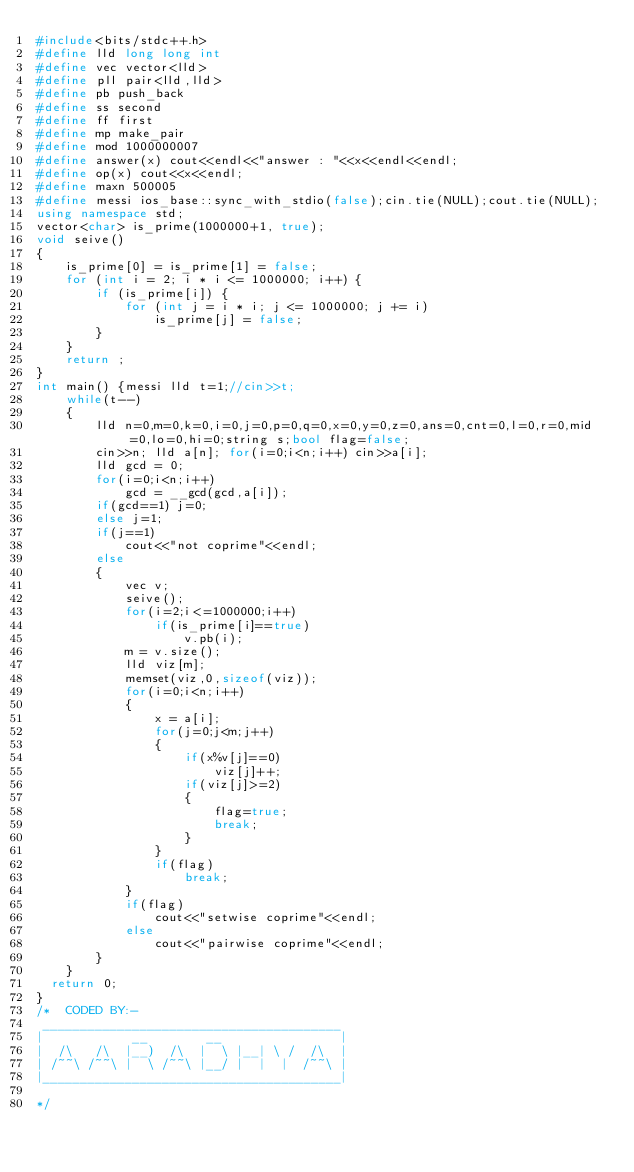Convert code to text. <code><loc_0><loc_0><loc_500><loc_500><_C++_>#include<bits/stdc++.h>
#define lld long long int
#define vec vector<lld>
#define pll pair<lld,lld>
#define pb push_back
#define ss second
#define ff first
#define mp make_pair
#define mod 1000000007
#define answer(x) cout<<endl<<"answer : "<<x<<endl<<endl;
#define op(x) cout<<x<<endl;
#define maxn 500005
#define messi ios_base::sync_with_stdio(false);cin.tie(NULL);cout.tie(NULL);
using namespace std;
vector<char> is_prime(1000000+1, true);
void seive()
{
    is_prime[0] = is_prime[1] = false;
    for (int i = 2; i * i <= 1000000; i++) {
        if (is_prime[i]) {
            for (int j = i * i; j <= 1000000; j += i)
                is_prime[j] = false;
        }
    }
    return ;
}
int main() {messi lld t=1;//cin>>t;
    while(t--)
    {
        lld n=0,m=0,k=0,i=0,j=0,p=0,q=0,x=0,y=0,z=0,ans=0,cnt=0,l=0,r=0,mid=0,lo=0,hi=0;string s;bool flag=false;
        cin>>n; lld a[n]; for(i=0;i<n;i++) cin>>a[i];
        lld gcd = 0;
        for(i=0;i<n;i++)
            gcd = __gcd(gcd,a[i]);
        if(gcd==1) j=0;
        else j=1;
        if(j==1)
            cout<<"not coprime"<<endl;
        else
        {
            vec v;
            seive();
            for(i=2;i<=1000000;i++)
                if(is_prime[i]==true)
                    v.pb(i);
            m = v.size();
            lld viz[m];
            memset(viz,0,sizeof(viz));
            for(i=0;i<n;i++)
            {
                x = a[i];
                for(j=0;j<m;j++)
                {
                    if(x%v[j]==0)
                        viz[j]++;
                    if(viz[j]>=2)
                    {
                        flag=true;
                        break;
                    }
                }
                if(flag)
                    break;
            }
            if(flag)
                cout<<"setwise coprime"<<endl;
            else
                cout<<"pairwise coprime"<<endl;
        }
    }
	return 0;
}
/*  CODED BY:-
 ________________________________________
|            __        __                |
|  /\   /\  |__)  /\  |  \ |__| \ /  /\  |
| /~~\ /~~\ |  \ /~~\ |__/ |  |  |  /~~\ |
|________________________________________|

*/
</code> 